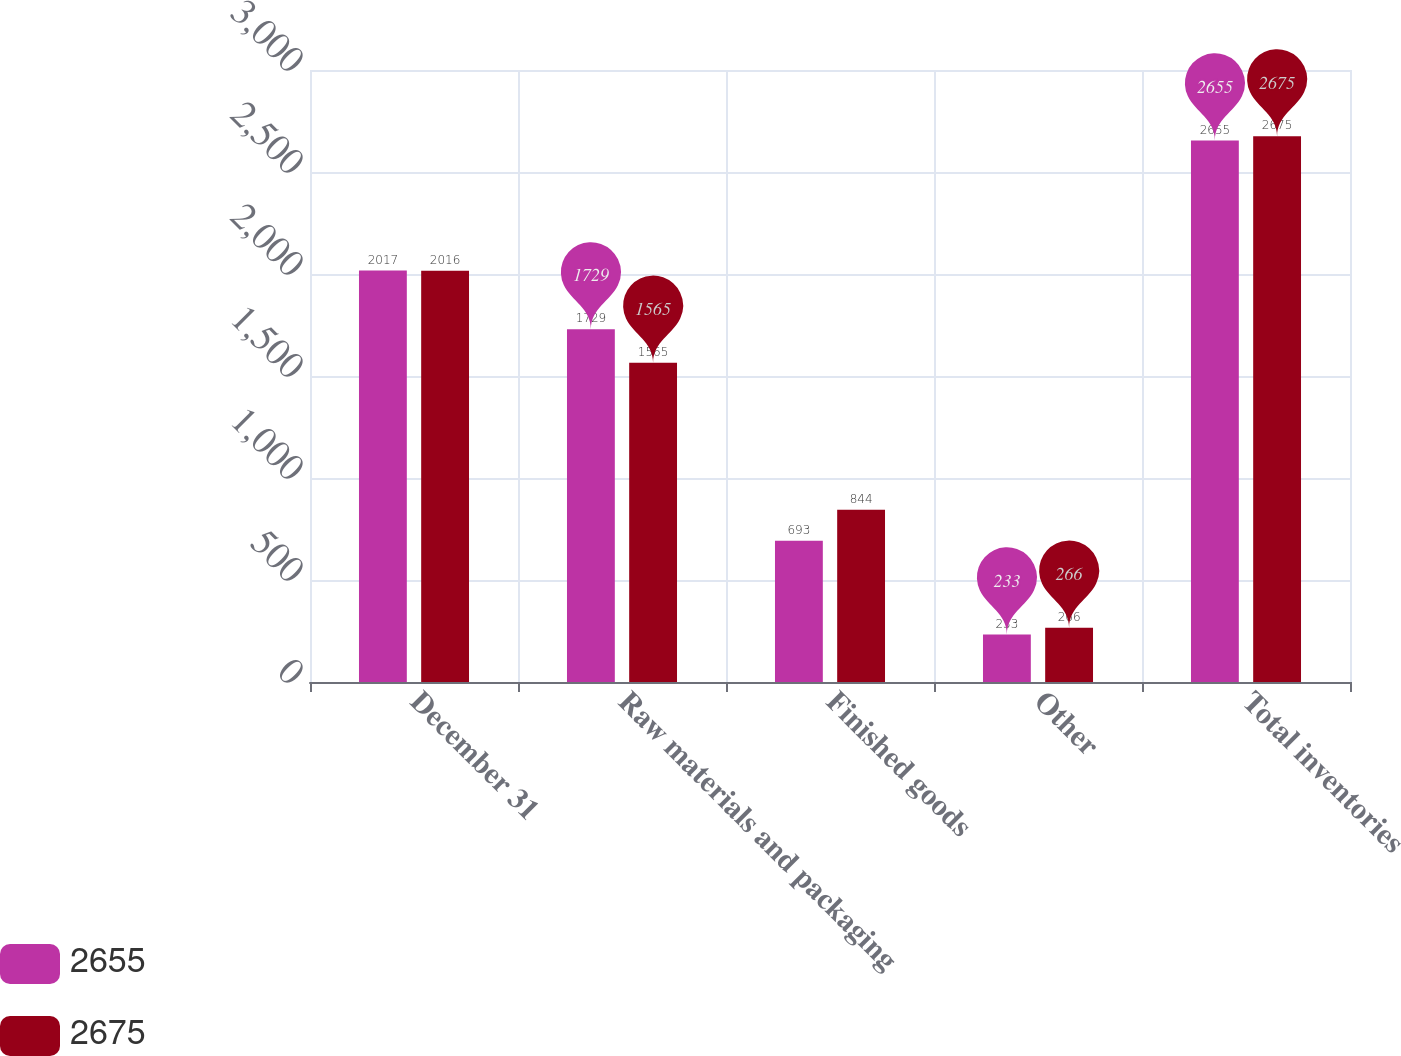<chart> <loc_0><loc_0><loc_500><loc_500><stacked_bar_chart><ecel><fcel>December 31<fcel>Raw materials and packaging<fcel>Finished goods<fcel>Other<fcel>Total inventories<nl><fcel>2655<fcel>2017<fcel>1729<fcel>693<fcel>233<fcel>2655<nl><fcel>2675<fcel>2016<fcel>1565<fcel>844<fcel>266<fcel>2675<nl></chart> 